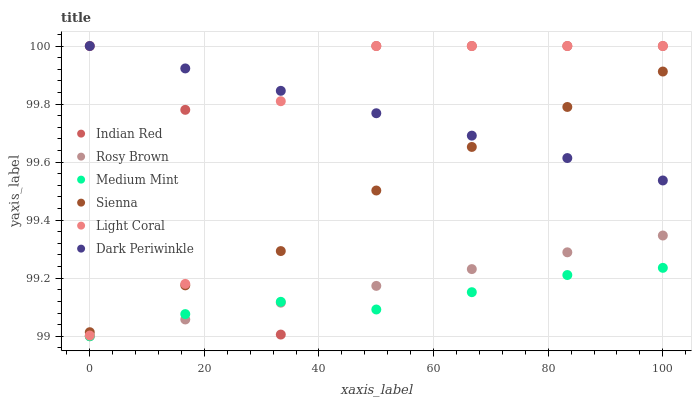Does Medium Mint have the minimum area under the curve?
Answer yes or no. Yes. Does Indian Red have the maximum area under the curve?
Answer yes or no. Yes. Does Light Coral have the minimum area under the curve?
Answer yes or no. No. Does Light Coral have the maximum area under the curve?
Answer yes or no. No. Is Rosy Brown the smoothest?
Answer yes or no. Yes. Is Indian Red the roughest?
Answer yes or no. Yes. Is Light Coral the smoothest?
Answer yes or no. No. Is Light Coral the roughest?
Answer yes or no. No. Does Medium Mint have the lowest value?
Answer yes or no. Yes. Does Light Coral have the lowest value?
Answer yes or no. No. Does Dark Periwinkle have the highest value?
Answer yes or no. Yes. Does Rosy Brown have the highest value?
Answer yes or no. No. Is Rosy Brown less than Dark Periwinkle?
Answer yes or no. Yes. Is Dark Periwinkle greater than Medium Mint?
Answer yes or no. Yes. Does Light Coral intersect Dark Periwinkle?
Answer yes or no. Yes. Is Light Coral less than Dark Periwinkle?
Answer yes or no. No. Is Light Coral greater than Dark Periwinkle?
Answer yes or no. No. Does Rosy Brown intersect Dark Periwinkle?
Answer yes or no. No. 